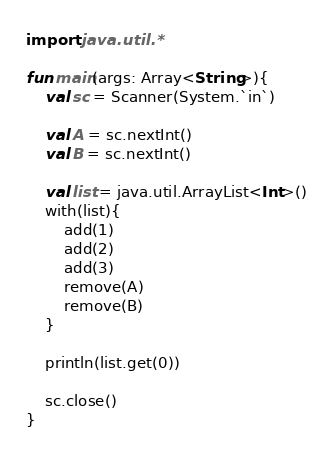Convert code to text. <code><loc_0><loc_0><loc_500><loc_500><_Kotlin_>import java.util.*

fun main(args: Array<String>){
    val sc = Scanner(System.`in`)

    val A = sc.nextInt()
    val B = sc.nextInt()

    val list = java.util.ArrayList<Int>()
    with(list){
        add(1)
        add(2)
        add(3)
        remove(A)
        remove(B)
    }

    println(list.get(0))

    sc.close()
}</code> 